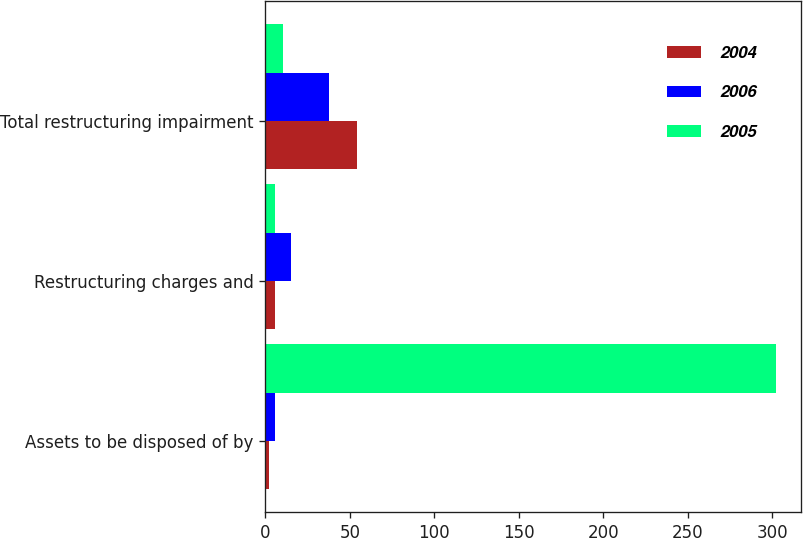Convert chart. <chart><loc_0><loc_0><loc_500><loc_500><stacked_bar_chart><ecel><fcel>Assets to be disposed of by<fcel>Restructuring charges and<fcel>Total restructuring impairment<nl><fcel>2004<fcel>2<fcel>6<fcel>54<nl><fcel>2006<fcel>6<fcel>15<fcel>38<nl><fcel>2005<fcel>302<fcel>6<fcel>10.5<nl></chart> 